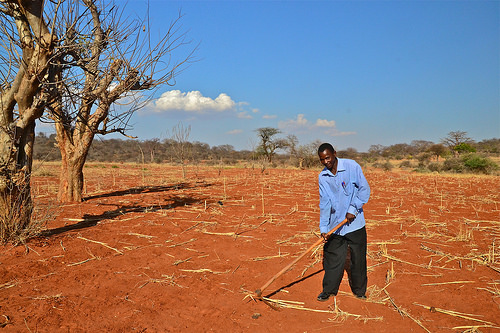<image>
Can you confirm if the man is under the tree? No. The man is not positioned under the tree. The vertical relationship between these objects is different. 